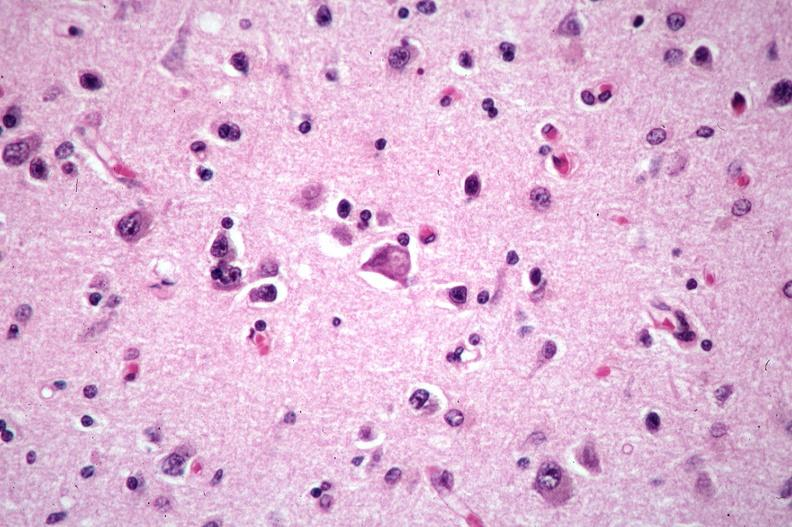s pyelonephritis carcinoma in prostate present?
Answer the question using a single word or phrase. No 